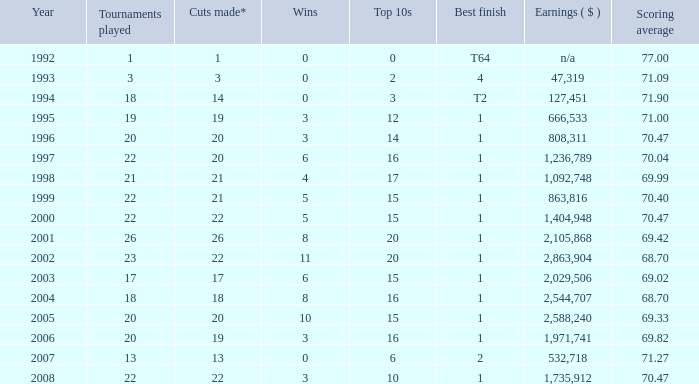Tell me the scoring average for year less than 1998 and wins more than 3 70.04. 